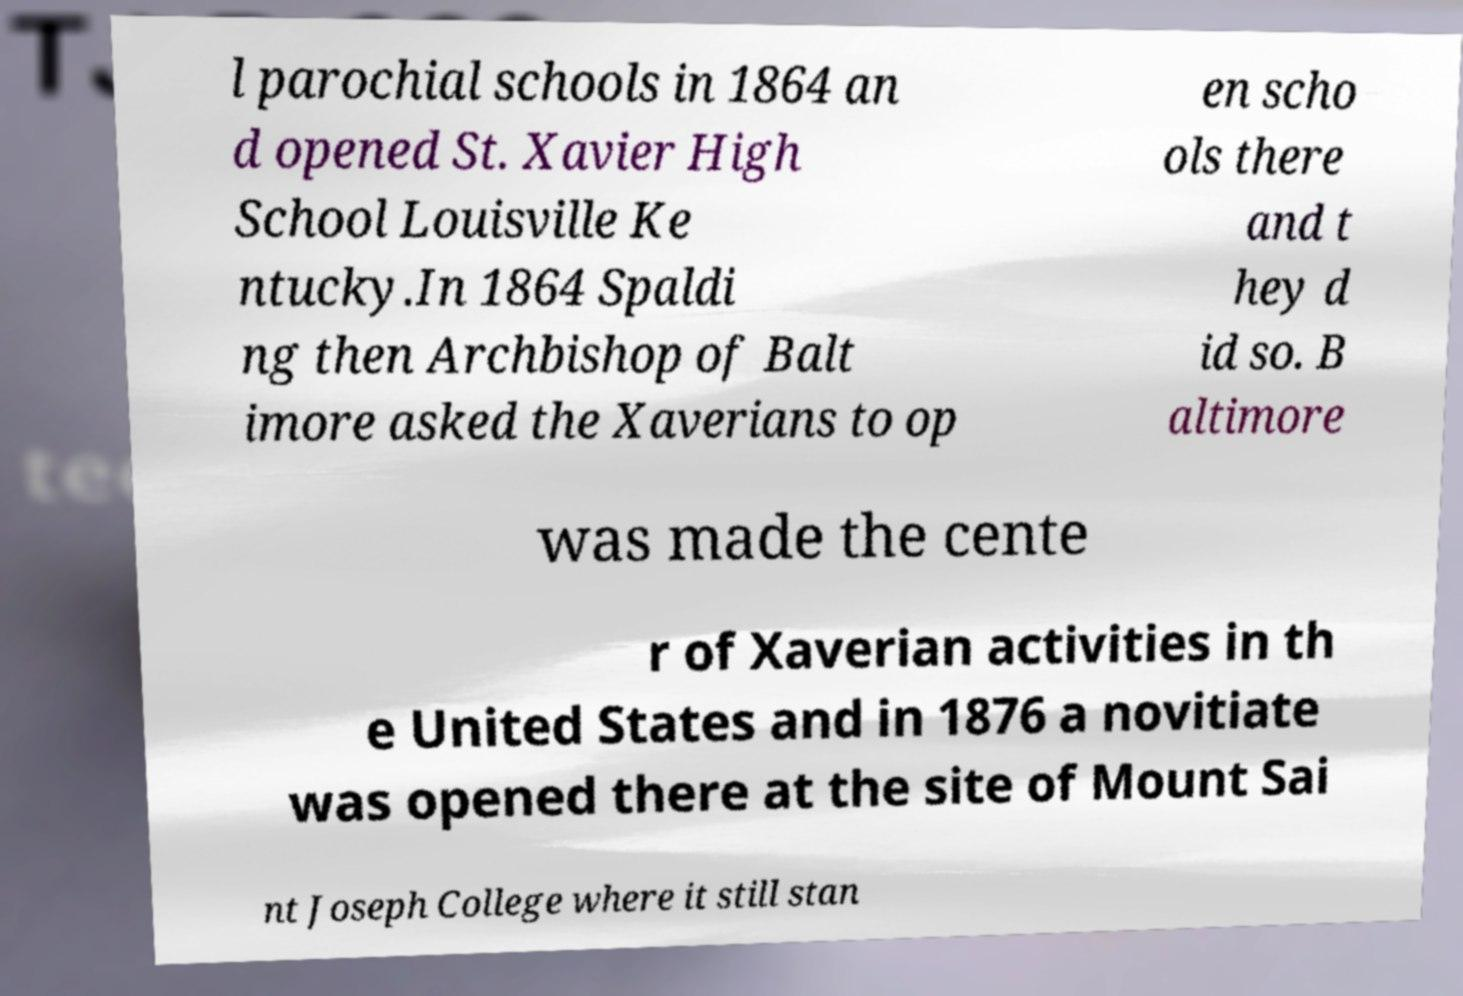Can you read and provide the text displayed in the image?This photo seems to have some interesting text. Can you extract and type it out for me? l parochial schools in 1864 an d opened St. Xavier High School Louisville Ke ntucky.In 1864 Spaldi ng then Archbishop of Balt imore asked the Xaverians to op en scho ols there and t hey d id so. B altimore was made the cente r of Xaverian activities in th e United States and in 1876 a novitiate was opened there at the site of Mount Sai nt Joseph College where it still stan 